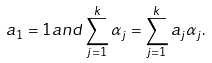<formula> <loc_0><loc_0><loc_500><loc_500>a _ { 1 } = 1 a n d \sum _ { j = 1 } ^ { k } \alpha _ { j } = \sum _ { j = 1 } ^ { k } a _ { j } \alpha _ { j } .</formula> 